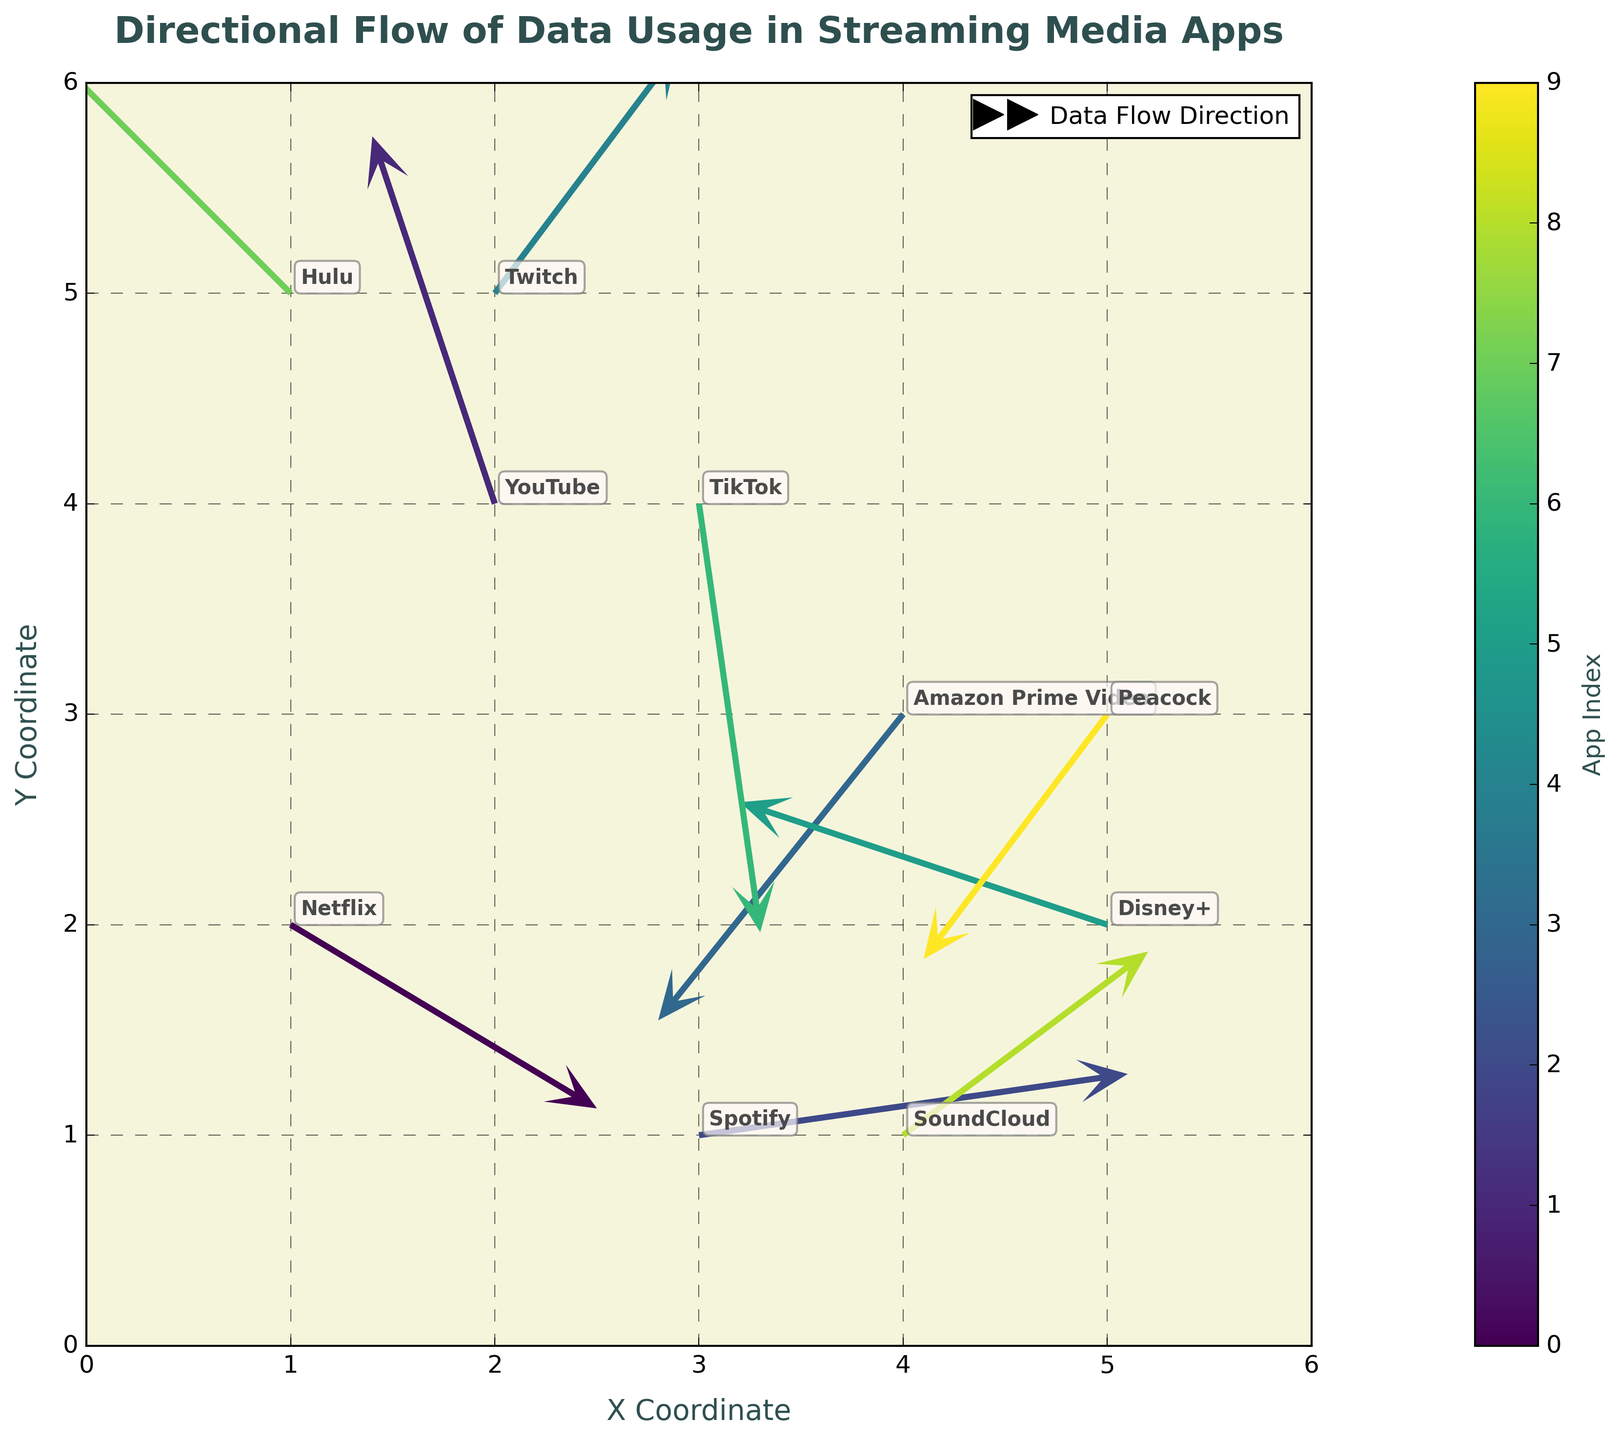What is the title of the figure? The title is usually located at the top of the figure and is used to describe what the figure is about. It is often in a larger or bold font. In this figure, it states: "Directional Flow of Data Usage in Streaming Media Apps."
Answer: Directional Flow of Data Usage in Streaming Media Apps What are the x and y-coordinate ranges used in the plot? By inspecting the axes in the plot, you can see the ranges for the x-coordinate and y-coordinate. The x-axis ranges from 0 to 6, and the y-axis ranges from 0 to 6.
Answer: 0 to 6 Which app has a data flow direction towards the left and slightly upwards? To find this out, observe the direction of the arrows. If the arrow points left and slightly upwards, it means the u component is negative, and the v component is positive. In this case, YouTube has u = -0.2 and v = 0.6.
Answer: YouTube How many apps are there in total in the figure? Each app's data usage direction is represented by an arrow with the app name as annotation. Counting each unique annotation, we find there are 10 apps in total in the figure.
Answer: 10 Which app shows the strongest data flow towards the right? The strength of the data flow towards the right is determined by the largest positive u component. Spotify has u = 0.7, which is the highest positive value for u.
Answer: Spotify Among Hulu and TikTok, which app flows more upwards? Compare the v components for Hulu and TikTok. Hulu has v = 0.5, while TikTok has v = -0.7. Since 0.5 is greater than -0.7, Hulu flows more upwards.
Answer: Hulu What is the direction of data usage for Amazon Prime Video? Look at the direction of the arrow associated with Amazon Prime Video. The u component is -0.4 (towards left) and the v component is -0.5 (downwards). Therefore, the direction is left and downwards.
Answer: Left and downwards Which app's data usage flows downwards and to the right? Analyzing the arrows that point downwards and to the right, we look for positive u and negative v components. SoundCloud has u = 0.4 and v = 0.3. However, TikTok has v = -0.7, TikTok has the appropriate direction (though it flows slightly upwards).
Answer: None flow both down and right Is the magnitude of the data flow higher for Peacock or Netflix? For each app, calculate the magnitude as √(u² + v²). For Peacock, magnitude = √((-0.3)² + (-0.4)²) ≈ 0.5. For Netflix, magnitude = √((0.5)² + (-0.3)²) ≈ 0.58. Compare these values to find that Netflix has a higher magnitude.
Answer: Netflix Which app has an upward data flow that is the steepest? The steepness of an upward flow depends on the v component being the largest positive value. Twitch has the highest v component (0.4), indicating the steepest upward flow.
Answer: Twitch 